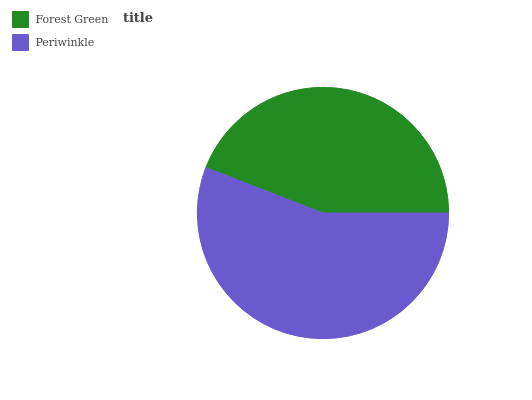Is Forest Green the minimum?
Answer yes or no. Yes. Is Periwinkle the maximum?
Answer yes or no. Yes. Is Periwinkle the minimum?
Answer yes or no. No. Is Periwinkle greater than Forest Green?
Answer yes or no. Yes. Is Forest Green less than Periwinkle?
Answer yes or no. Yes. Is Forest Green greater than Periwinkle?
Answer yes or no. No. Is Periwinkle less than Forest Green?
Answer yes or no. No. Is Periwinkle the high median?
Answer yes or no. Yes. Is Forest Green the low median?
Answer yes or no. Yes. Is Forest Green the high median?
Answer yes or no. No. Is Periwinkle the low median?
Answer yes or no. No. 